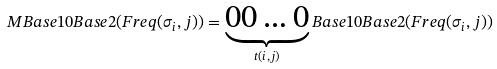<formula> <loc_0><loc_0><loc_500><loc_500>M B a s e 1 0 B a s e 2 ( F r e q ( \sigma _ { i } , j ) ) = \underbrace { 0 0 \dots { 0 } } _ { t ( i , j ) } B a s e 1 0 B a s e 2 ( F r e q ( \sigma _ { i } , j ) )</formula> 